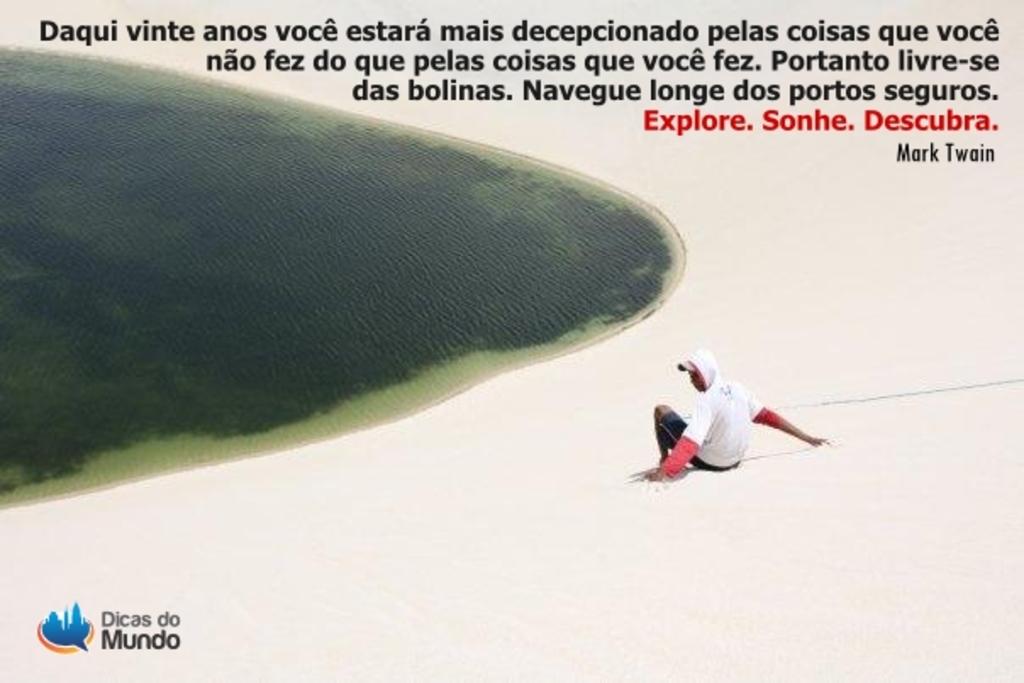Who is the author of the quote given here?
Offer a very short reply. Mark twain. What is the organization mentioned in the bottom left corner?
Make the answer very short. Dicas do mundo. 